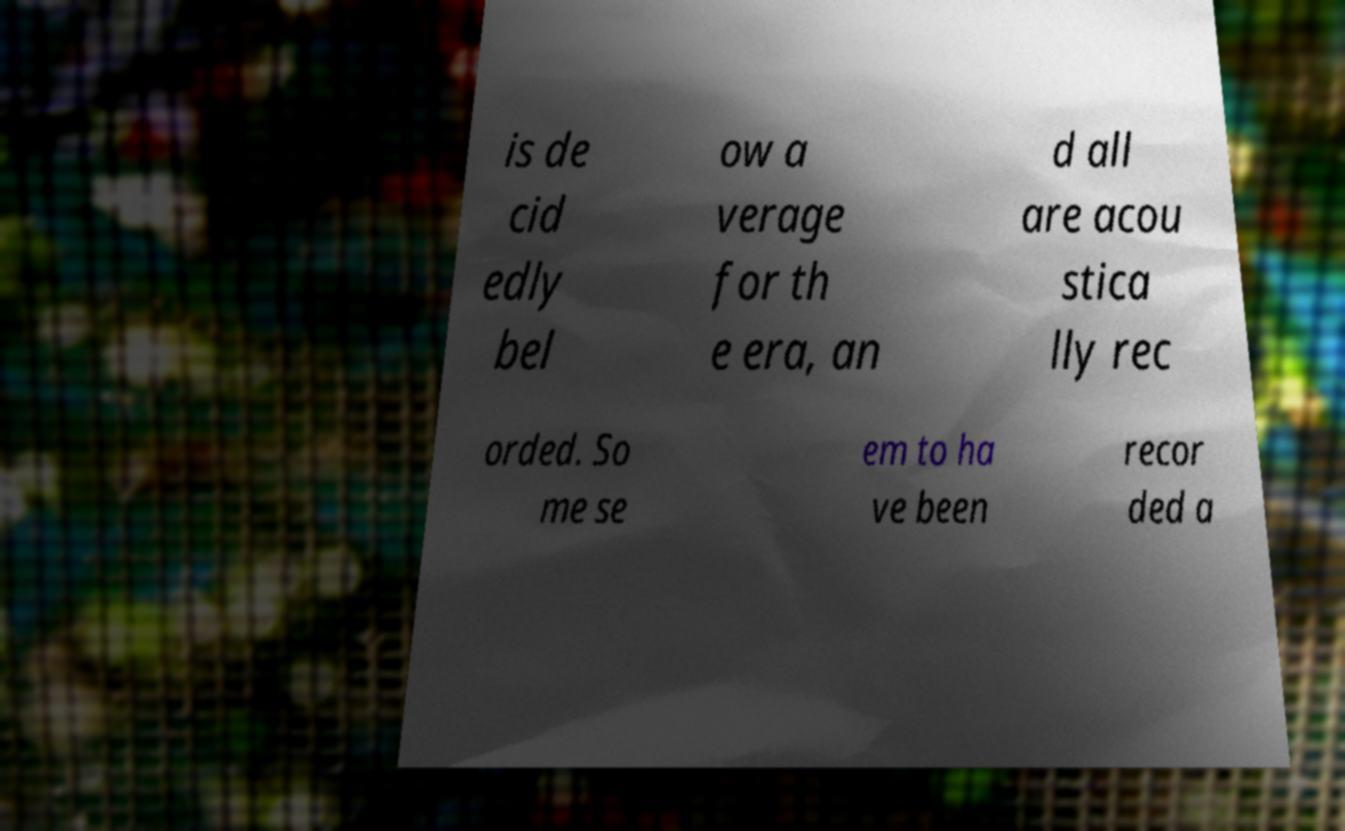Please identify and transcribe the text found in this image. is de cid edly bel ow a verage for th e era, an d all are acou stica lly rec orded. So me se em to ha ve been recor ded a 